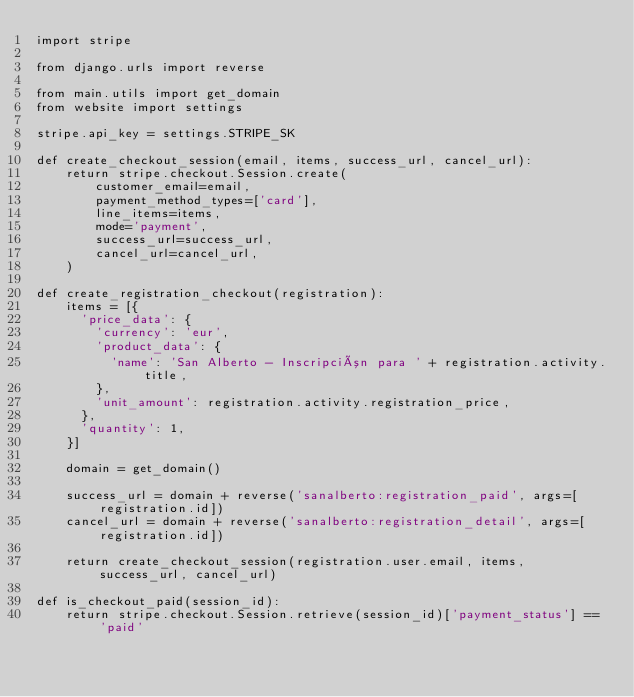Convert code to text. <code><loc_0><loc_0><loc_500><loc_500><_Python_>import stripe

from django.urls import reverse

from main.utils import get_domain
from website import settings

stripe.api_key = settings.STRIPE_SK

def create_checkout_session(email, items, success_url, cancel_url):
    return stripe.checkout.Session.create(
        customer_email=email,
        payment_method_types=['card'],
        line_items=items,
        mode='payment',
        success_url=success_url,
        cancel_url=cancel_url,
    )

def create_registration_checkout(registration):
    items = [{
      'price_data': {
        'currency': 'eur',
        'product_data': {
          'name': 'San Alberto - Inscripción para ' + registration.activity.title,
        },
        'unit_amount': registration.activity.registration_price,
      },
      'quantity': 1,
    }]

    domain = get_domain()

    success_url = domain + reverse('sanalberto:registration_paid', args=[registration.id])
    cancel_url = domain + reverse('sanalberto:registration_detail', args=[registration.id])

    return create_checkout_session(registration.user.email, items, success_url, cancel_url)

def is_checkout_paid(session_id):
    return stripe.checkout.Session.retrieve(session_id)['payment_status'] == 'paid'
</code> 